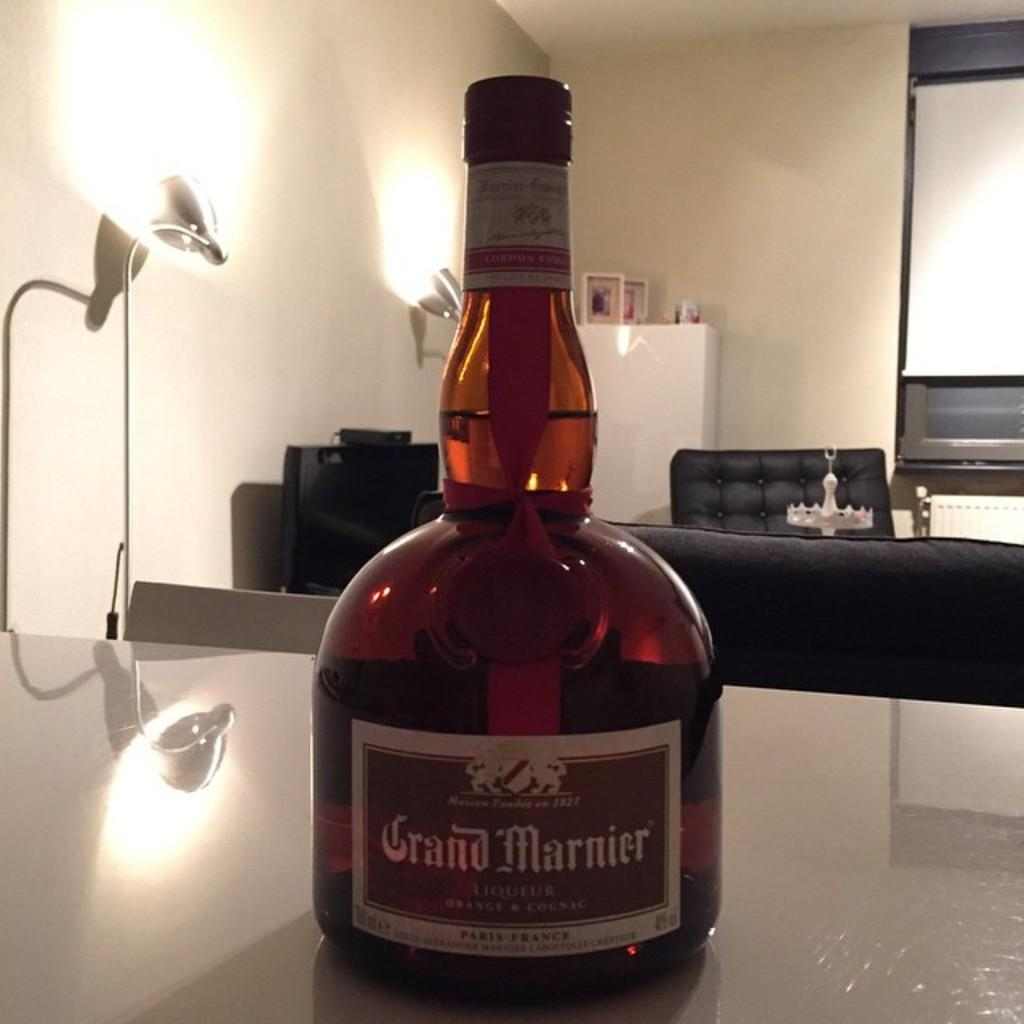<image>
Give a short and clear explanation of the subsequent image. A bottle of Grand Marnier sits on the table with black couches in the background. 